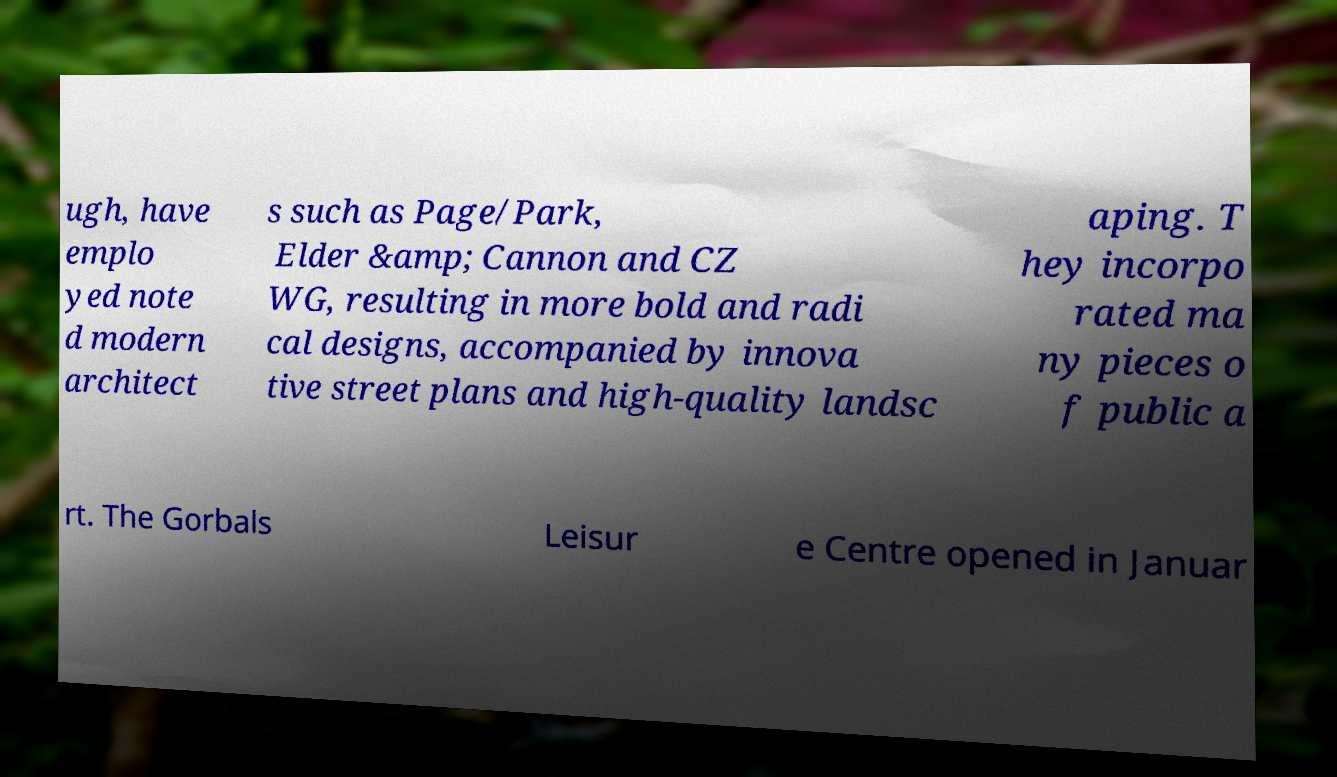For documentation purposes, I need the text within this image transcribed. Could you provide that? ugh, have emplo yed note d modern architect s such as Page/Park, Elder &amp; Cannon and CZ WG, resulting in more bold and radi cal designs, accompanied by innova tive street plans and high-quality landsc aping. T hey incorpo rated ma ny pieces o f public a rt. The Gorbals Leisur e Centre opened in Januar 